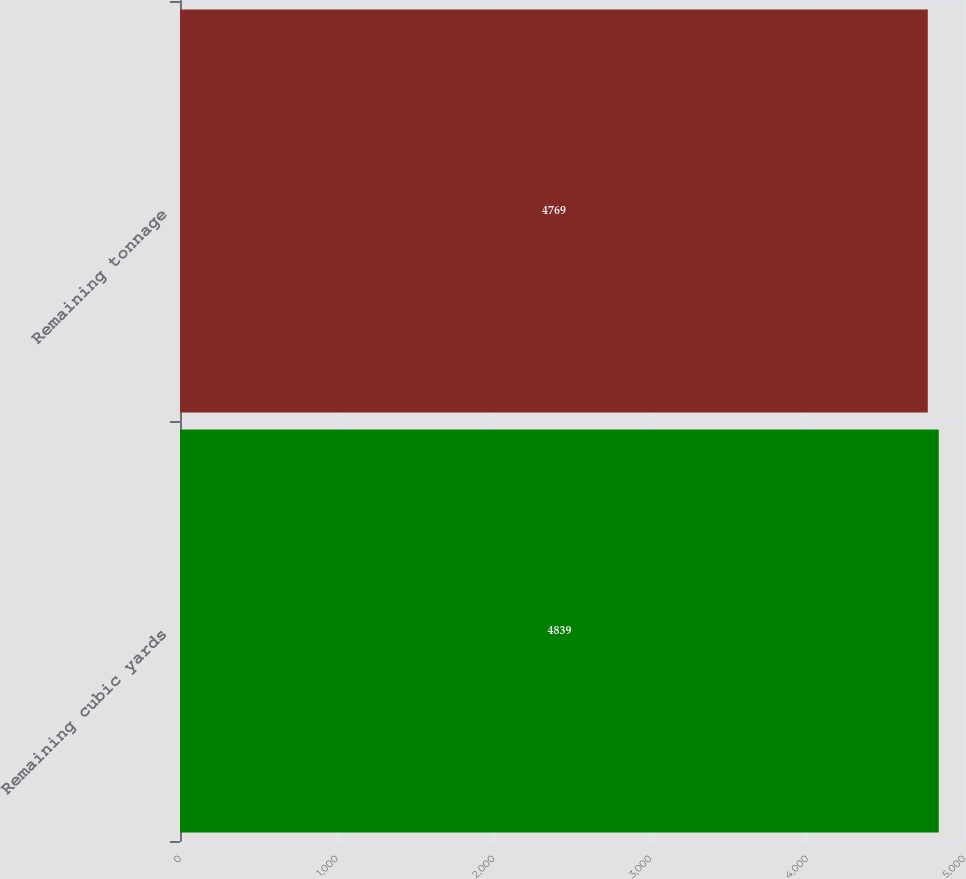<chart> <loc_0><loc_0><loc_500><loc_500><bar_chart><fcel>Remaining cubic yards<fcel>Remaining tonnage<nl><fcel>4839<fcel>4769<nl></chart> 